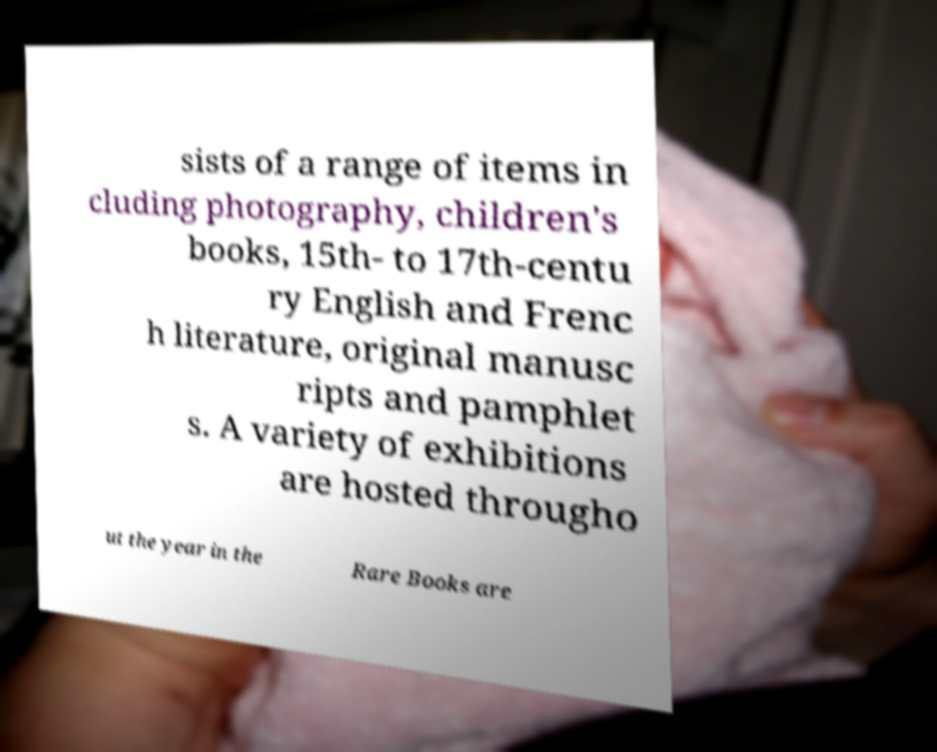For documentation purposes, I need the text within this image transcribed. Could you provide that? sists of a range of items in cluding photography, children's books, 15th- to 17th-centu ry English and Frenc h literature, original manusc ripts and pamphlet s. A variety of exhibitions are hosted througho ut the year in the Rare Books are 